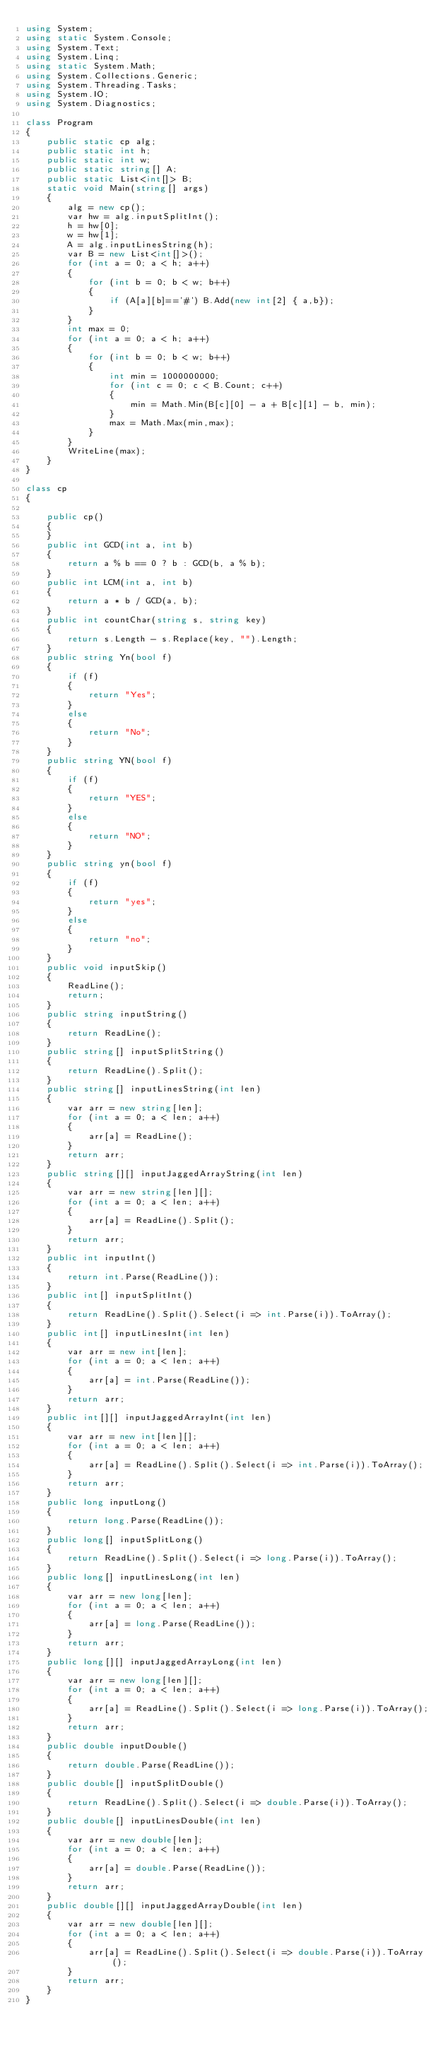Convert code to text. <code><loc_0><loc_0><loc_500><loc_500><_C#_>using System;
using static System.Console;
using System.Text;
using System.Linq;
using static System.Math;
using System.Collections.Generic;
using System.Threading.Tasks;
using System.IO;
using System.Diagnostics;

class Program
{
    public static cp alg;
    public static int h;
    public static int w;
    public static string[] A;
    public static List<int[]> B;
    static void Main(string[] args)
    {
        alg = new cp();
        var hw = alg.inputSplitInt();
        h = hw[0];
        w = hw[1];
        A = alg.inputLinesString(h);
        var B = new List<int[]>();
        for (int a = 0; a < h; a++)
        {
            for (int b = 0; b < w; b++)
            {
                if (A[a][b]=='#') B.Add(new int[2] { a,b});
            }
        }
        int max = 0;
        for (int a = 0; a < h; a++)
        {
            for (int b = 0; b < w; b++)
            {
                int min = 1000000000;
                for (int c = 0; c < B.Count; c++)
                {
                    min = Math.Min(B[c][0] - a + B[c][1] - b, min);
                }
                max = Math.Max(min,max);
            }
        }
        WriteLine(max);
    }
}

class cp
{

    public cp()
    {
    }
    public int GCD(int a, int b)
    {
        return a % b == 0 ? b : GCD(b, a % b);
    }
    public int LCM(int a, int b)
    {
        return a * b / GCD(a, b);
    }
    public int countChar(string s, string key)
    {
        return s.Length - s.Replace(key, "").Length;
    }
    public string Yn(bool f)
    {
        if (f)
        {
            return "Yes";
        }
        else
        {
            return "No";
        }
    }
    public string YN(bool f)
    {
        if (f)
        {
            return "YES";
        }
        else
        {
            return "NO";
        }
    }
    public string yn(bool f)
    {
        if (f)
        {
            return "yes";
        }
        else
        {
            return "no";
        }
    }
    public void inputSkip()
    {
        ReadLine();
        return;
    }
    public string inputString()
    {
        return ReadLine();
    }
    public string[] inputSplitString()
    {
        return ReadLine().Split();
    }
    public string[] inputLinesString(int len)
    {
        var arr = new string[len];
        for (int a = 0; a < len; a++)
        {
            arr[a] = ReadLine();
        }
        return arr;
    }
    public string[][] inputJaggedArrayString(int len)
    {
        var arr = new string[len][];
        for (int a = 0; a < len; a++)
        {
            arr[a] = ReadLine().Split();
        }
        return arr;
    }
    public int inputInt()
    {
        return int.Parse(ReadLine());
    }
    public int[] inputSplitInt()
    {
        return ReadLine().Split().Select(i => int.Parse(i)).ToArray();
    }
    public int[] inputLinesInt(int len)
    {
        var arr = new int[len];
        for (int a = 0; a < len; a++)
        {
            arr[a] = int.Parse(ReadLine());
        }
        return arr;
    }
    public int[][] inputJaggedArrayInt(int len)
    {
        var arr = new int[len][];
        for (int a = 0; a < len; a++)
        {
            arr[a] = ReadLine().Split().Select(i => int.Parse(i)).ToArray();
        }
        return arr;
    }
    public long inputLong()
    {
        return long.Parse(ReadLine());
    }
    public long[] inputSplitLong()
    {
        return ReadLine().Split().Select(i => long.Parse(i)).ToArray();
    }
    public long[] inputLinesLong(int len)
    {
        var arr = new long[len];
        for (int a = 0; a < len; a++)
        {
            arr[a] = long.Parse(ReadLine());
        }
        return arr;
    }
    public long[][] inputJaggedArrayLong(int len)
    {
        var arr = new long[len][];
        for (int a = 0; a < len; a++)
        {
            arr[a] = ReadLine().Split().Select(i => long.Parse(i)).ToArray();
        }
        return arr;
    }
    public double inputDouble()
    {
        return double.Parse(ReadLine());
    }
    public double[] inputSplitDouble()
    {
        return ReadLine().Split().Select(i => double.Parse(i)).ToArray();
    }
    public double[] inputLinesDouble(int len)
    {
        var arr = new double[len];
        for (int a = 0; a < len; a++)
        {
            arr[a] = double.Parse(ReadLine());
        }
        return arr;
    }
    public double[][] inputJaggedArrayDouble(int len)
    {
        var arr = new double[len][];
        for (int a = 0; a < len; a++)
        {
            arr[a] = ReadLine().Split().Select(i => double.Parse(i)).ToArray();
        }
        return arr;
    }
}</code> 